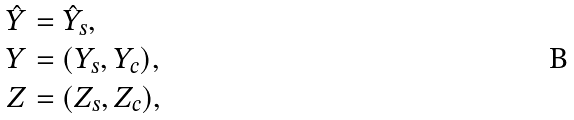Convert formula to latex. <formula><loc_0><loc_0><loc_500><loc_500>\hat { Y } & = \hat { Y } _ { s } , \\ Y & = ( Y _ { s } , Y _ { c } ) , \\ Z & = ( Z _ { s } , Z _ { c } ) ,</formula> 